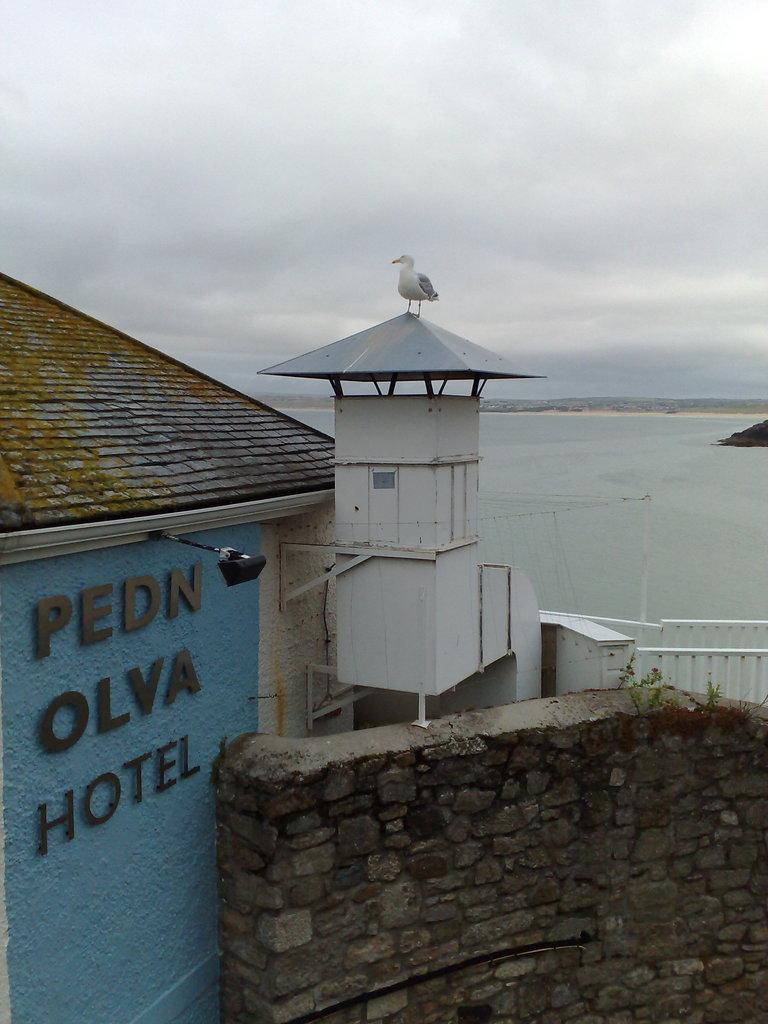What type of building is in the image? There is a hotel in the image. What is visible in the background of the image? There is a sea behind the hotel. Can you describe any animals present in the image? There is a bird standing on the roof of the hotel. What type of lipstick is the bird wearing in the image? There is no lipstick or any indication of makeup on the bird in the image. 